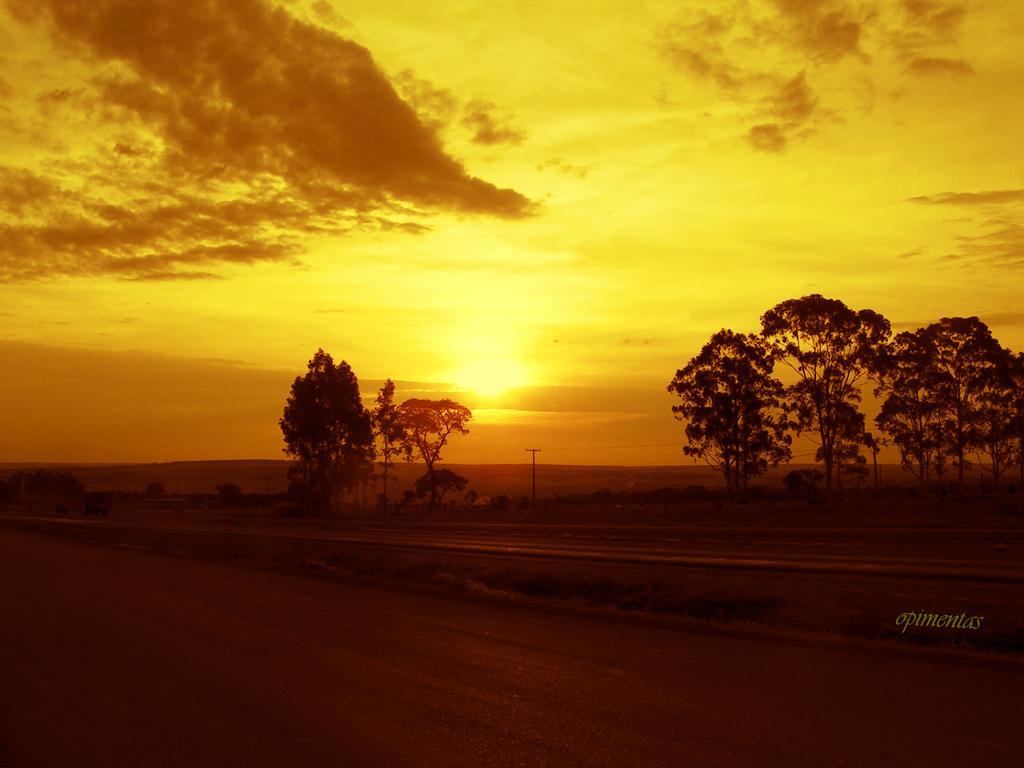Can you describe this image briefly? In this image I can see the ground, few trees and a pole. In the background I can see the sky and the sun. 